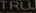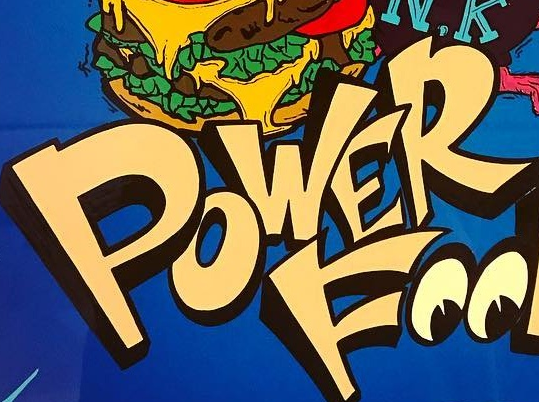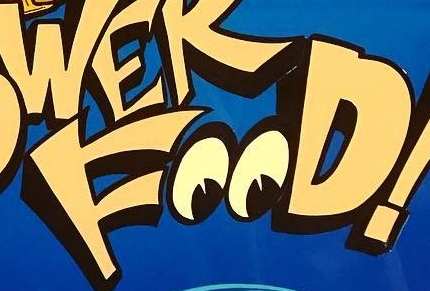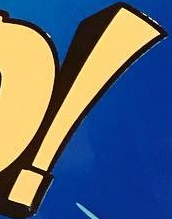Read the text from these images in sequence, separated by a semicolon. TRU; POWER; FOOD; ! 